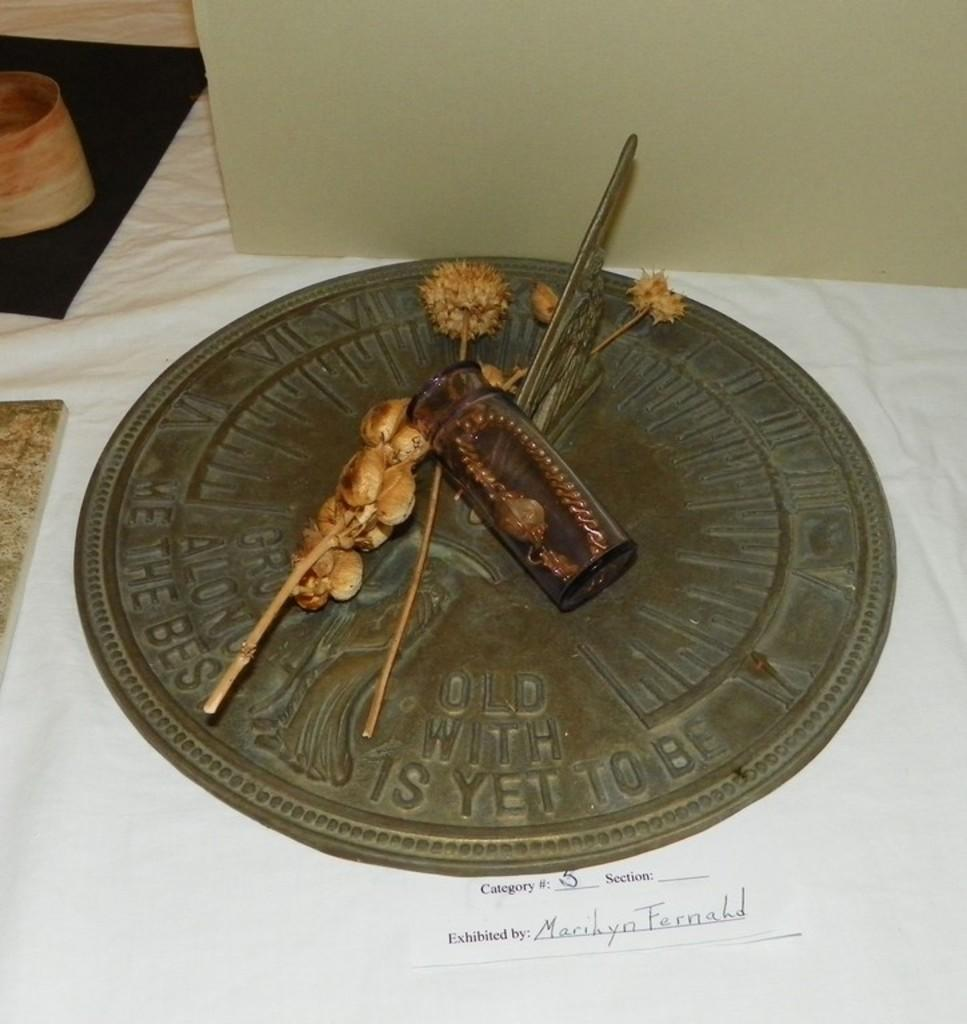What types of items can be seen in the image? There are artifacts and objects on a table in the image. Where are these items located? The objects are on a table in the image. Is there any text visible in the image? Yes, there is text on a paper at the bottom of the image. What type of island can be seen in the image? There is no island present in the image. How many eyes can be seen on the artifacts in the image? There are no eyes depicted on the artifacts in the image. 